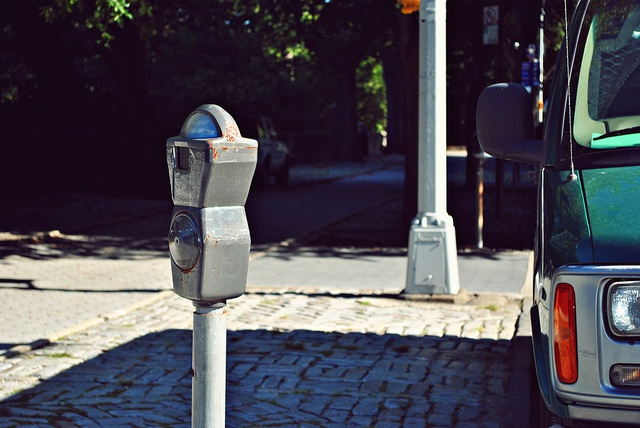Describe the objects in this image and their specific colors. I can see car in black, teal, gray, and navy tones, parking meter in black, darkgray, gray, and lightgray tones, parking meter in black, gray, and darkgray tones, and car in black, gray, and darkgray tones in this image. 